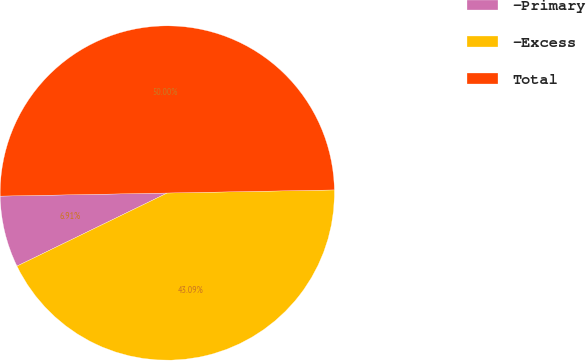Convert chart to OTSL. <chart><loc_0><loc_0><loc_500><loc_500><pie_chart><fcel>-Primary<fcel>-Excess<fcel>Total<nl><fcel>6.91%<fcel>43.09%<fcel>50.0%<nl></chart> 